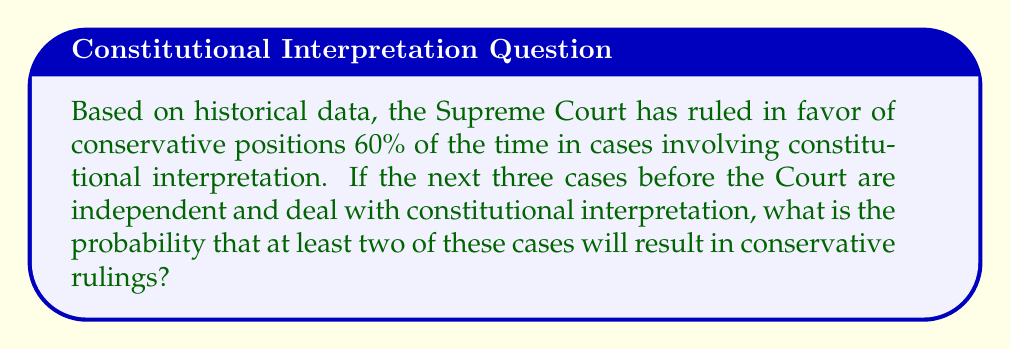Can you solve this math problem? Let's approach this step-by-step using the binomial probability formula:

1) Let $p$ be the probability of a conservative ruling. From the given data, $p = 0.60$.

2) We want at least 2 out of 3 cases to be conservative rulings. This can happen in two ways:
   - Exactly 2 out of 3 are conservative
   - All 3 are conservative

3) Let's calculate the probability of exactly 2 conservative rulings:
   $$P(X = 2) = \binom{3}{2} p^2 (1-p)^1 = 3 \cdot (0.60)^2 \cdot (0.40) = 0.432$$

4) Now, let's calculate the probability of all 3 being conservative:
   $$P(X = 3) = \binom{3}{3} p^3 = (0.60)^3 = 0.216$$

5) The probability of at least 2 conservative rulings is the sum of these probabilities:
   $$P(X \geq 2) = P(X = 2) + P(X = 3) = 0.432 + 0.216 = 0.648$$

6) Therefore, the probability is 0.648 or 64.8%.
Answer: 0.648 